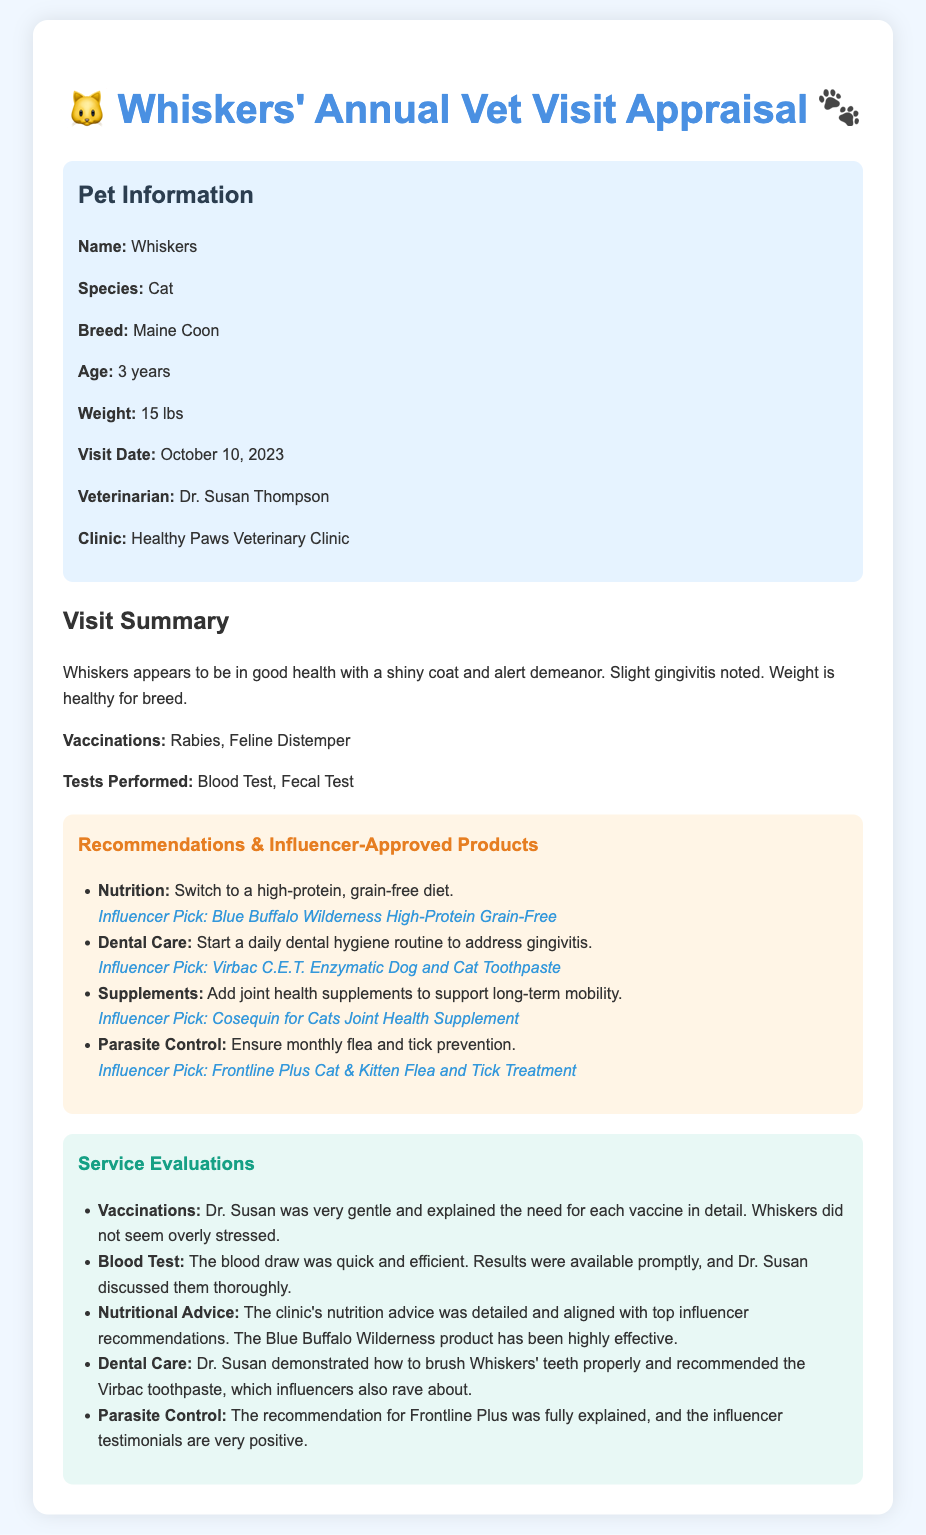What is the name of the pet? The document specifies the pet's name as Whiskers.
Answer: Whiskers What is the pet's weight? The weight of Whiskers is provided in the document as 15 lbs.
Answer: 15 lbs Who was the veterinarian? The document mentions Dr. Susan Thompson as the veterinarian.
Answer: Dr. Susan Thompson What vaccinations did Whiskers receive? The vaccinations listed in the document are Rabies and Feline Distemper.
Answer: Rabies, Feline Distemper What is the influencer's pick for nutritional improvement? The document indicates that the influencer's pick for nutrition is Blue Buffalo Wilderness High-Protein Grain-Free.
Answer: Blue Buffalo Wilderness High-Protein Grain-Free How was the blood test performed? The summary clearly states that the blood draw was quick and efficient.
Answer: Quick and efficient What specific dental care product was recommended? The document reveals the recommended dental care product as Virbac C.E.T. Enzymatic Dog and Cat Toothpaste.
Answer: Virbac C.E.T. Enzymatic Dog and Cat Toothpaste What is recommended for parasite control? According to the document, Frontline Plus Cat & Kitten Flea and Tick Treatment is recommended for parasite control.
Answer: Frontline Plus Cat & Kitten Flea and Tick Treatment How long has Whiskers been visiting the vet? The document states that Whiskers is 3 years old indicating that the visits have likely occurred regularly during this time.
Answer: 3 years 